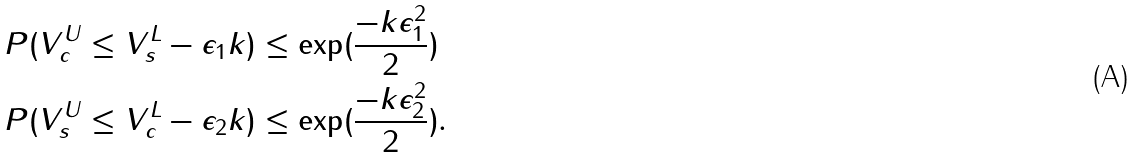<formula> <loc_0><loc_0><loc_500><loc_500>P ( V _ { c } ^ { U } & \leq V _ { s } ^ { L } - \epsilon _ { 1 } k ) \leq \exp ( \frac { - k \epsilon _ { 1 } ^ { 2 } } { 2 } ) \\ P ( V _ { s } ^ { U } & \leq V _ { c } ^ { L } - \epsilon _ { 2 } k ) \leq \exp ( \frac { - k \epsilon _ { 2 } ^ { 2 } } { 2 } ) .</formula> 